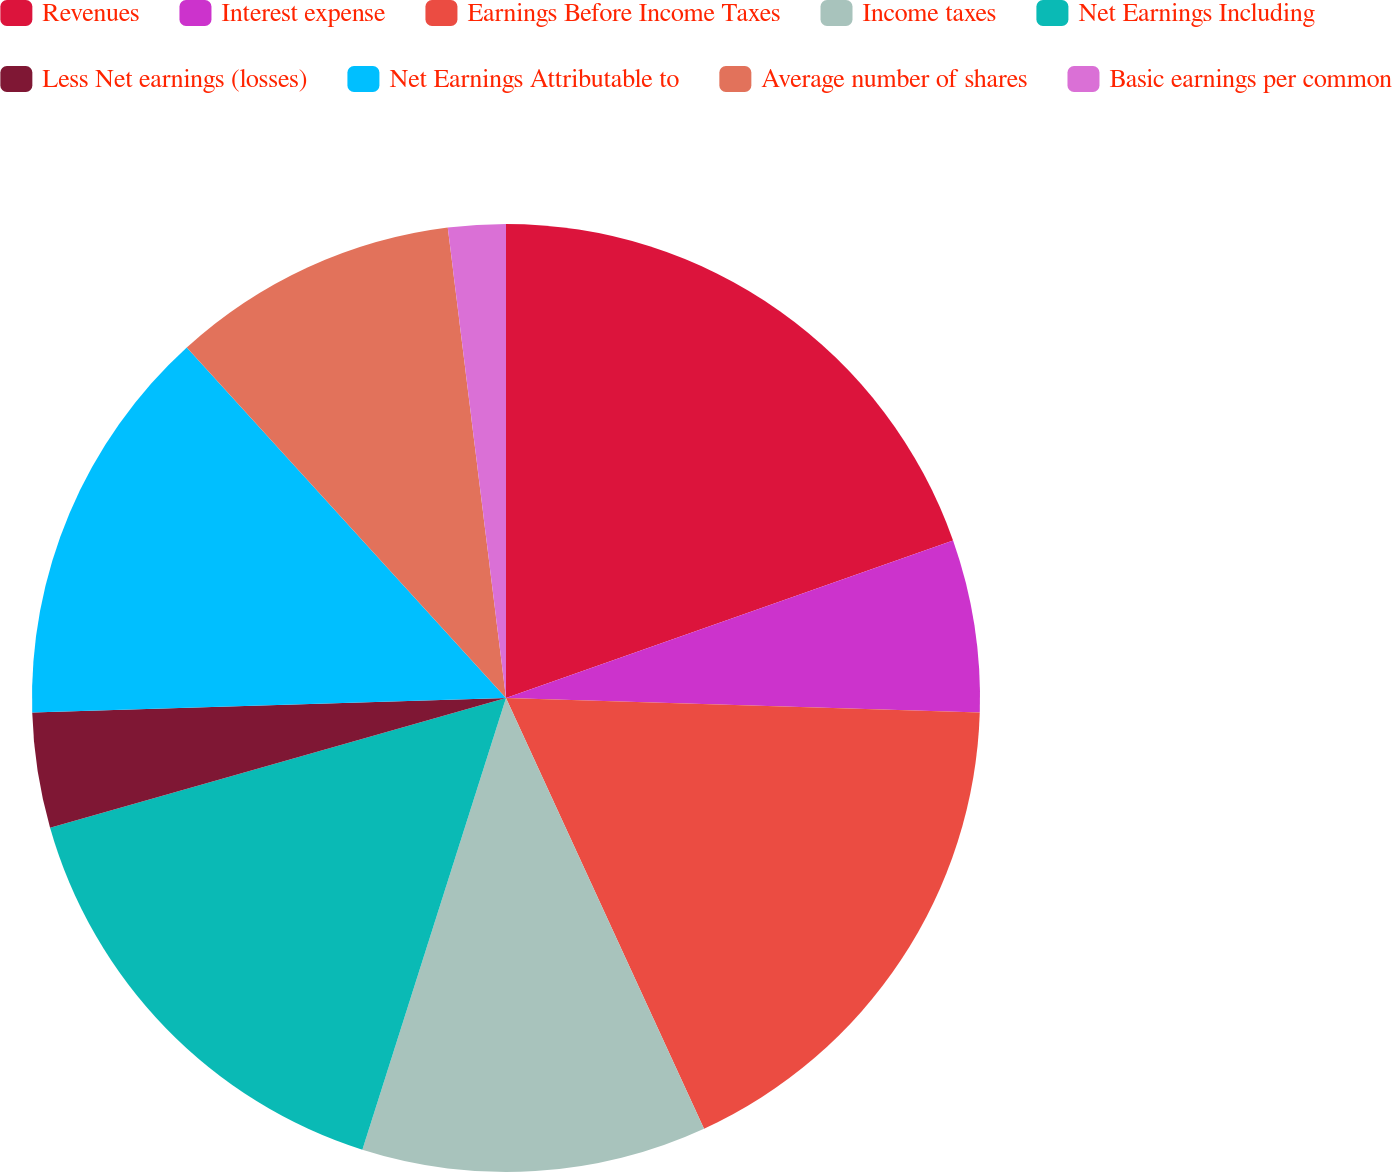Convert chart to OTSL. <chart><loc_0><loc_0><loc_500><loc_500><pie_chart><fcel>Revenues<fcel>Interest expense<fcel>Earnings Before Income Taxes<fcel>Income taxes<fcel>Net Earnings Including<fcel>Less Net earnings (losses)<fcel>Net Earnings Attributable to<fcel>Average number of shares<fcel>Basic earnings per common<nl><fcel>19.61%<fcel>5.88%<fcel>17.65%<fcel>11.76%<fcel>15.69%<fcel>3.92%<fcel>13.73%<fcel>9.8%<fcel>1.96%<nl></chart> 